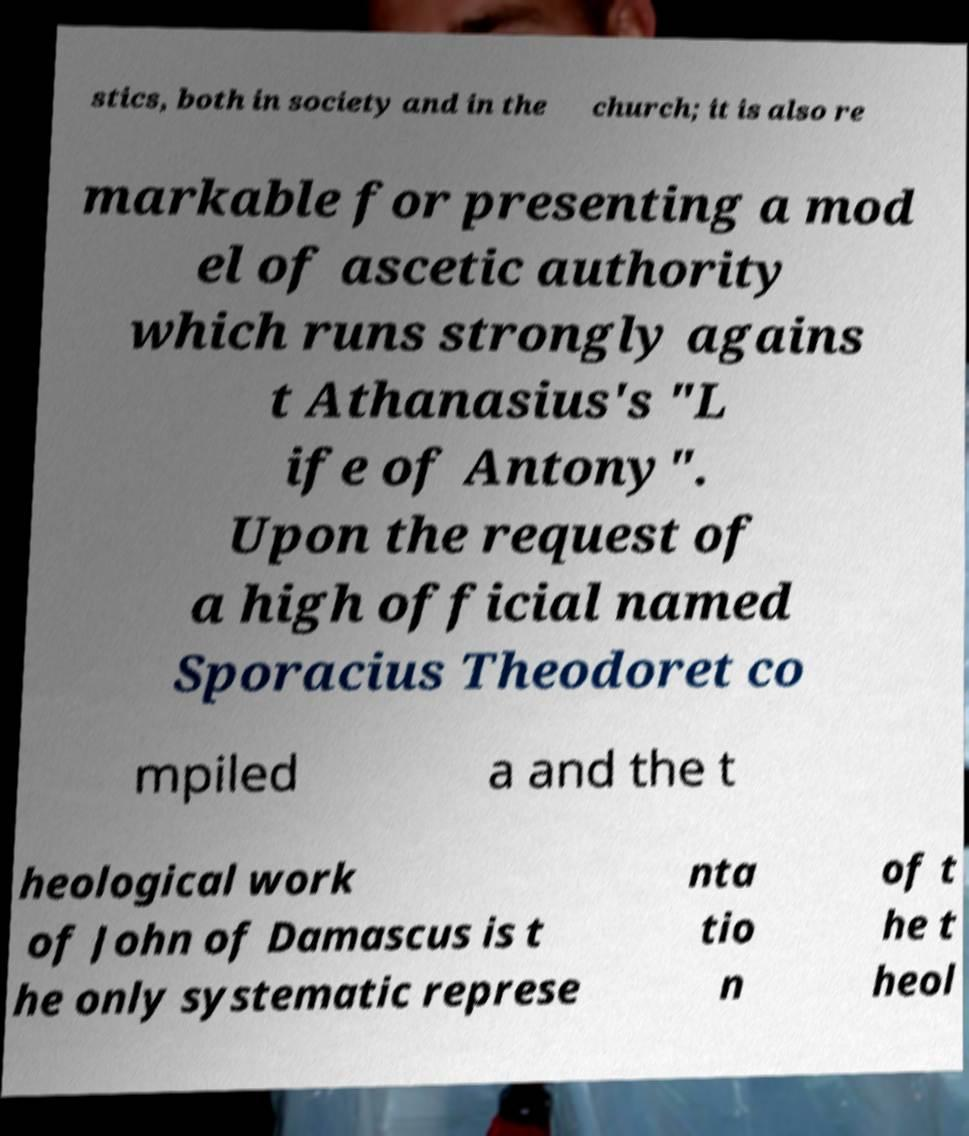For documentation purposes, I need the text within this image transcribed. Could you provide that? stics, both in society and in the church; it is also re markable for presenting a mod el of ascetic authority which runs strongly agains t Athanasius's "L ife of Antony". Upon the request of a high official named Sporacius Theodoret co mpiled a and the t heological work of John of Damascus is t he only systematic represe nta tio n of t he t heol 